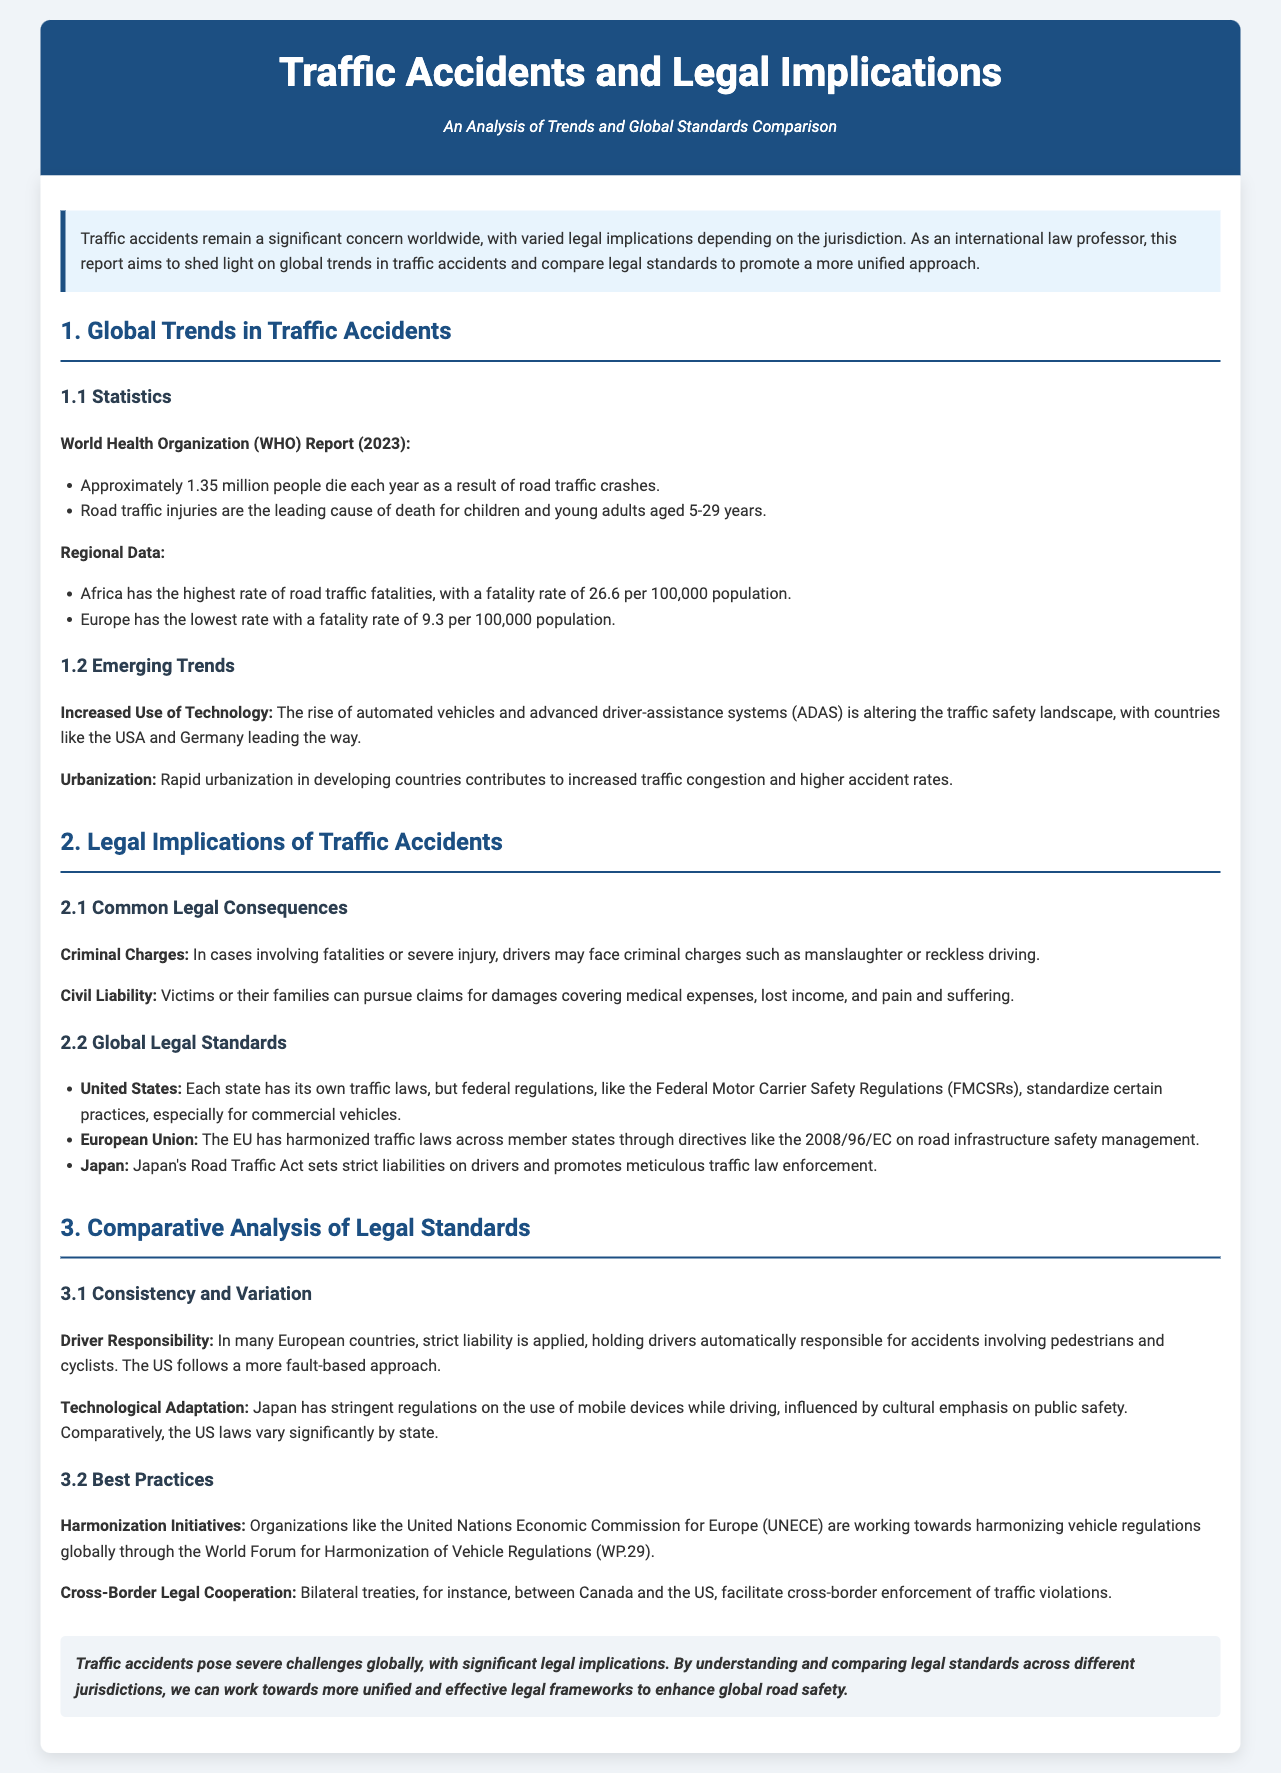what is the annual death toll from traffic crashes according to the WHO report? The report states that approximately 1.35 million people die each year as a result of road traffic crashes.
Answer: 1.35 million which region has the highest fatality rate for road traffic? The report mentions that Africa has the highest rate of road traffic fatalities.
Answer: Africa what is the fatality rate per 100,000 population in Europe? According to the statistics, Europe has a fatality rate of 9.3 per 100,000 population.
Answer: 9.3 what legal concept is applied in many European countries regarding driver responsibility? The document states that strict liability is applied in many European countries for accidents involving pedestrians and cyclists.
Answer: strict liability which organization is working towards harmonizing vehicle regulations globally? The report identifies the United Nations Economic Commission for Europe (UNECE) as working towards harmonizing vehicle regulations globally.
Answer: UNECE 